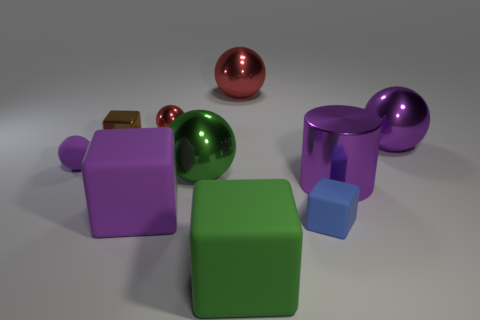Subtract all large green shiny balls. How many balls are left? 4 Subtract all green spheres. How many spheres are left? 4 Subtract all brown balls. Subtract all yellow cylinders. How many balls are left? 5 Subtract all blocks. How many objects are left? 6 Add 7 big green balls. How many big green balls are left? 8 Add 5 large red things. How many large red things exist? 6 Subtract 0 cyan blocks. How many objects are left? 10 Subtract all big purple rubber cubes. Subtract all tiny blue things. How many objects are left? 8 